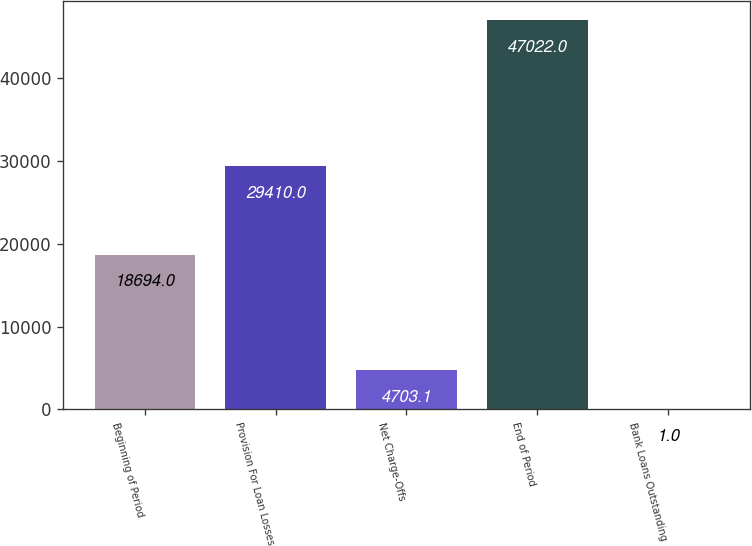Convert chart to OTSL. <chart><loc_0><loc_0><loc_500><loc_500><bar_chart><fcel>Beginning of Period<fcel>Provision For Loan Losses<fcel>Net Charge-Offs<fcel>End of Period<fcel>Bank Loans Outstanding<nl><fcel>18694<fcel>29410<fcel>4703.1<fcel>47022<fcel>1<nl></chart> 